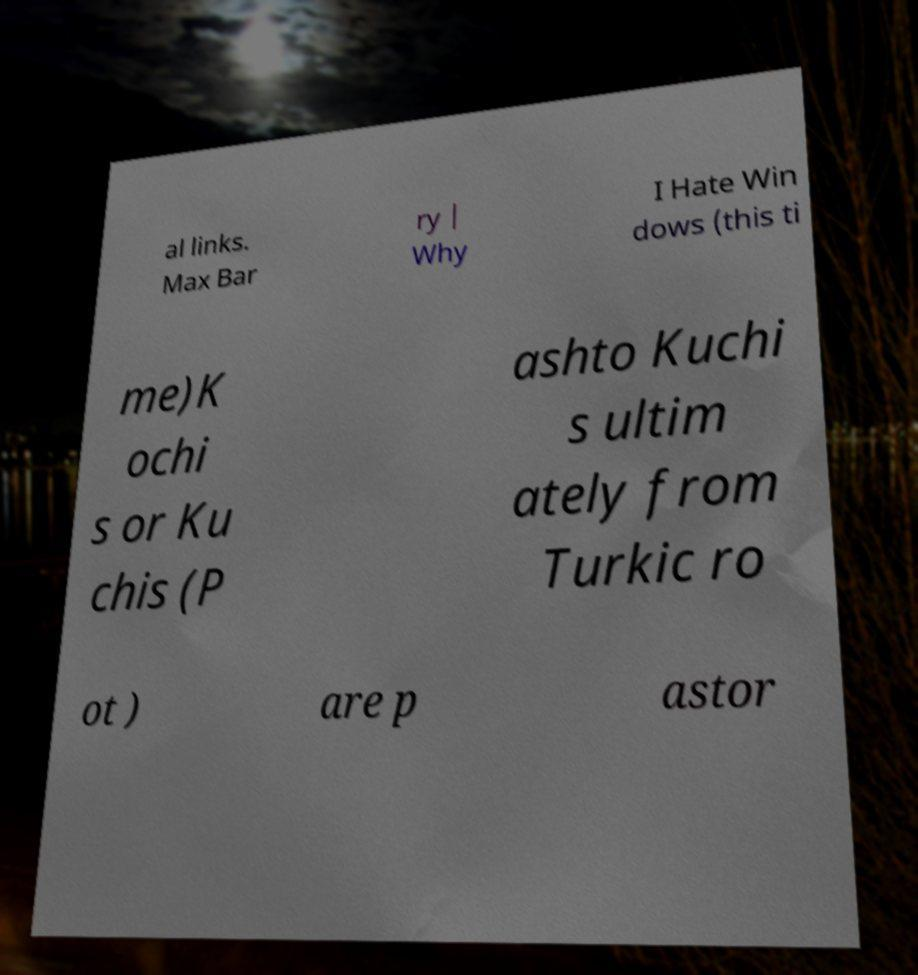Please read and relay the text visible in this image. What does it say? al links. Max Bar ry | Why I Hate Win dows (this ti me)K ochi s or Ku chis (P ashto Kuchi s ultim ately from Turkic ro ot ) are p astor 